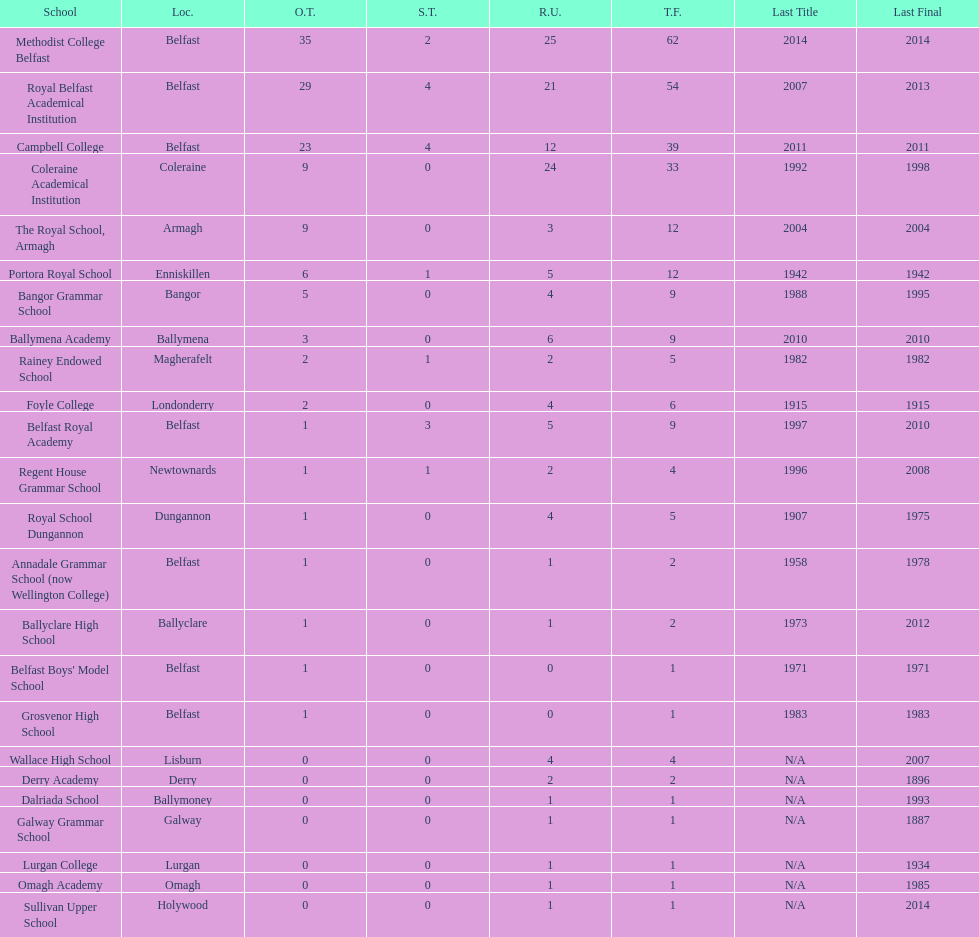Which two schools each had twelve total finals? The Royal School, Armagh, Portora Royal School. 